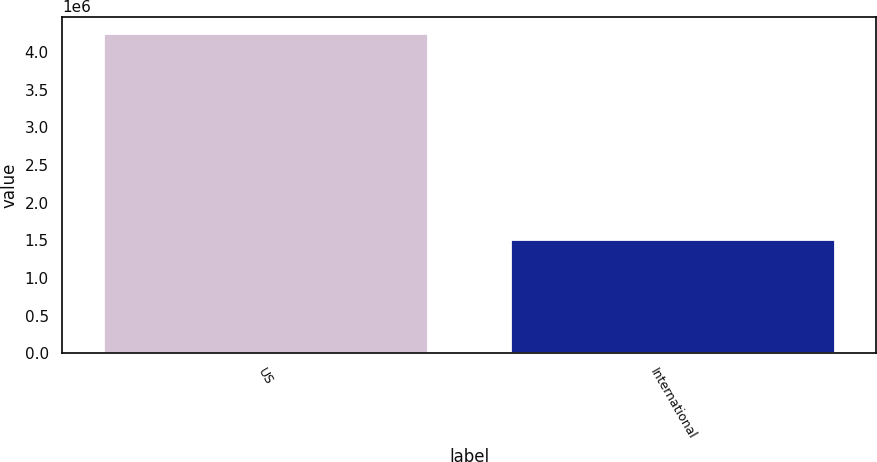Convert chart to OTSL. <chart><loc_0><loc_0><loc_500><loc_500><bar_chart><fcel>US<fcel>International<nl><fcel>4.256e+06<fcel>1.522e+06<nl></chart> 